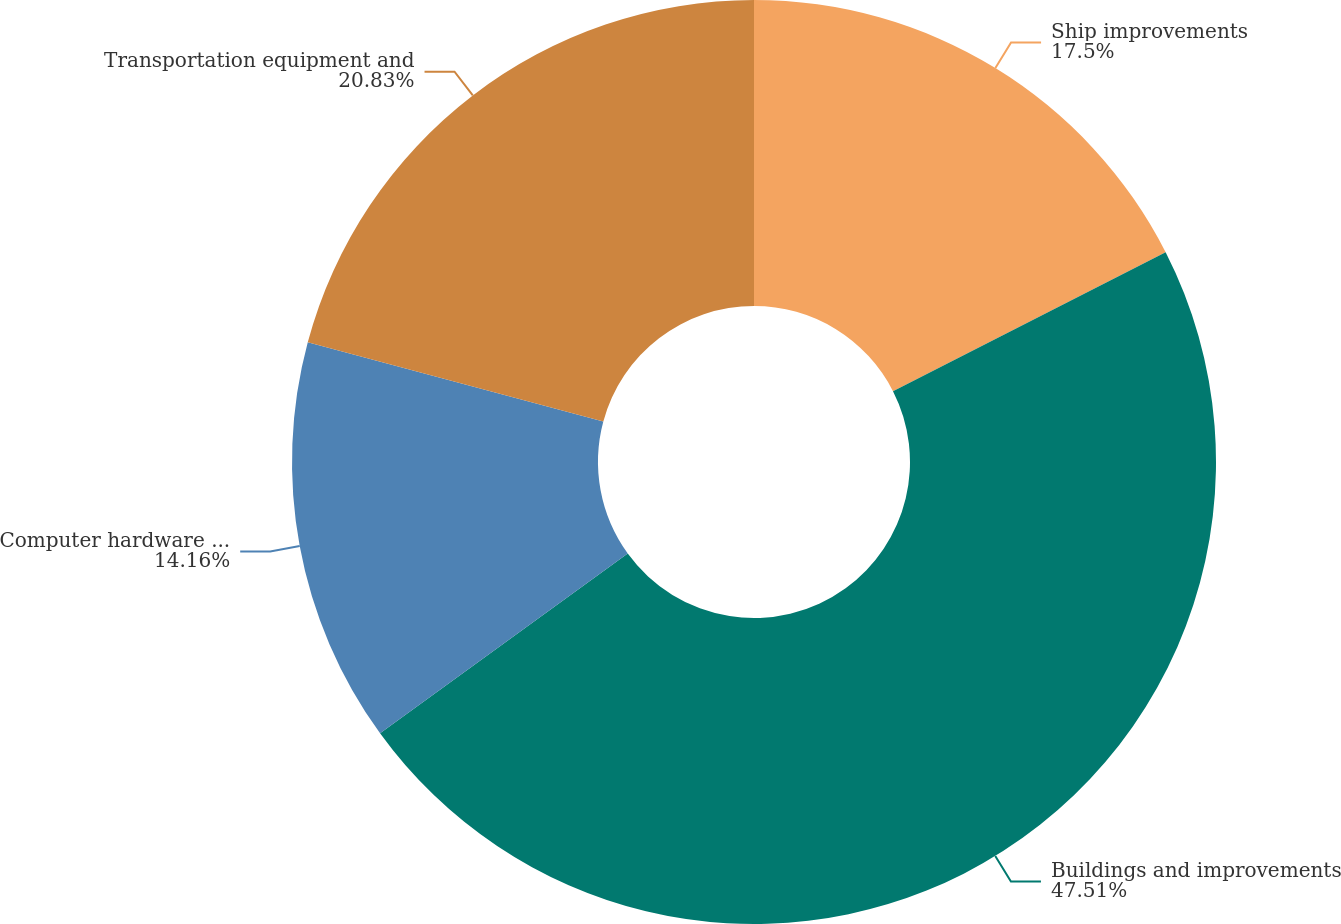Convert chart to OTSL. <chart><loc_0><loc_0><loc_500><loc_500><pie_chart><fcel>Ship improvements<fcel>Buildings and improvements<fcel>Computer hardware and software<fcel>Transportation equipment and<nl><fcel>17.5%<fcel>47.51%<fcel>14.16%<fcel>20.83%<nl></chart> 